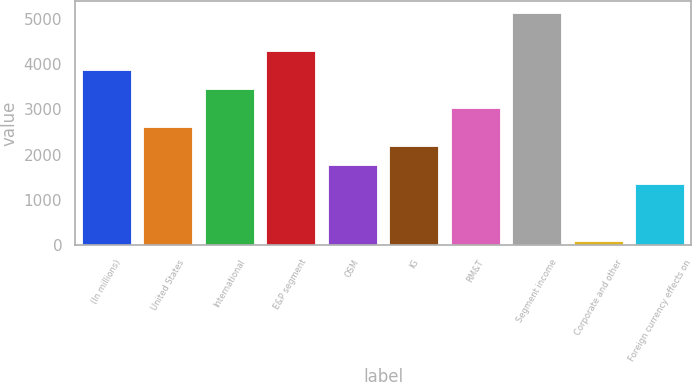<chart> <loc_0><loc_0><loc_500><loc_500><bar_chart><fcel>(In millions)<fcel>United States<fcel>International<fcel>E&P segment<fcel>OSM<fcel>IG<fcel>RM&T<fcel>Segment income<fcel>Corporate and other<fcel>Foreign currency effects on<nl><fcel>3873<fcel>2607<fcel>3451<fcel>4295<fcel>1763<fcel>2185<fcel>3029<fcel>5139<fcel>75<fcel>1341<nl></chart> 